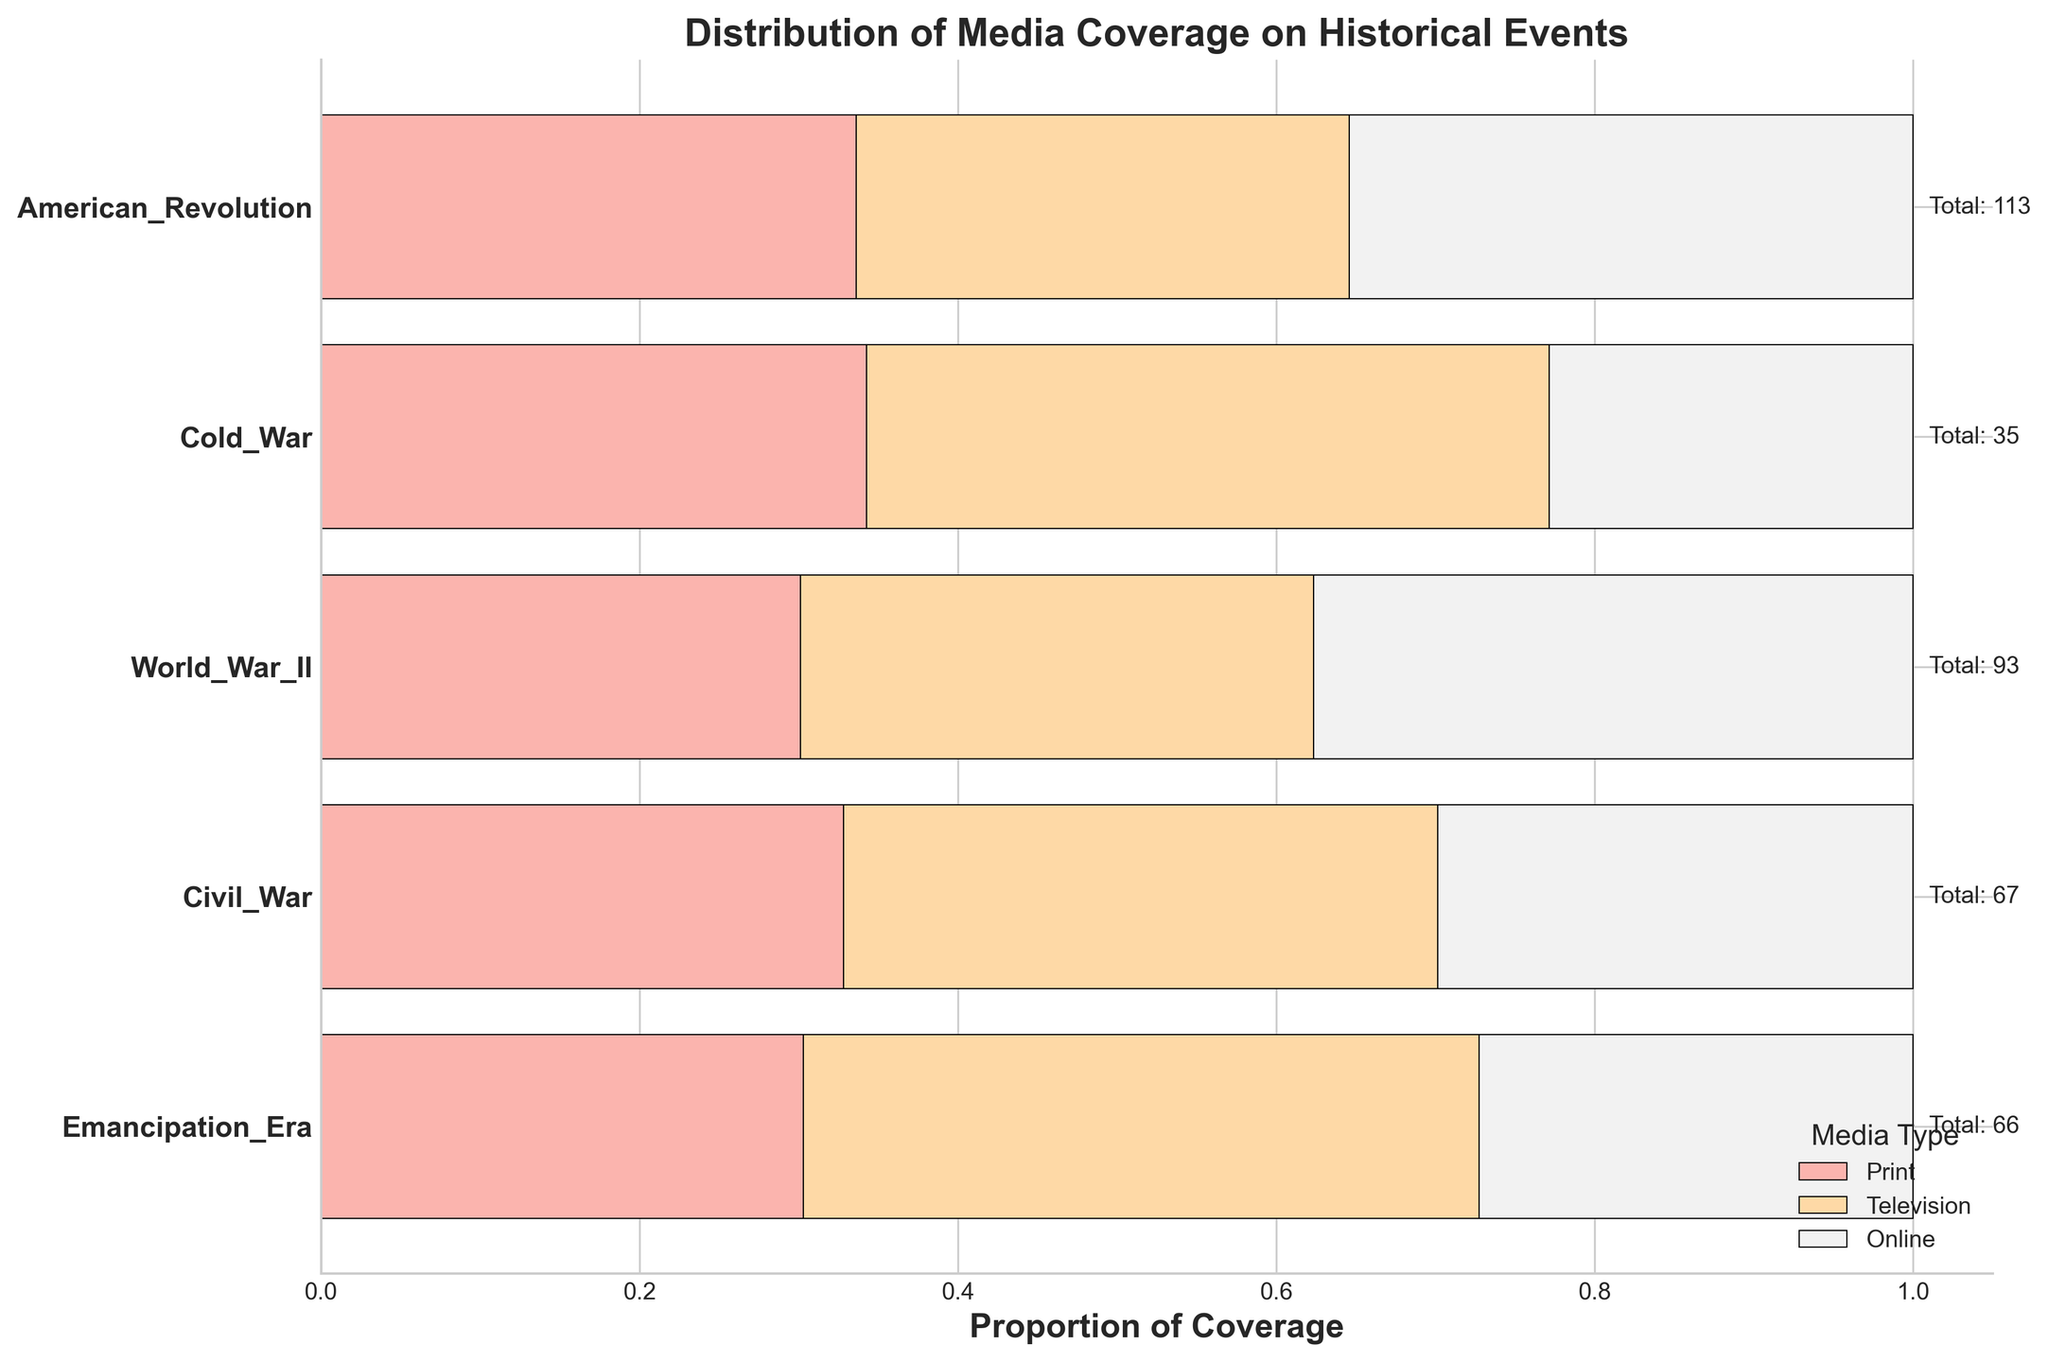What is the title of the plot? The title can be found at the top of the plot, usually in larger and bold text.
Answer: Distribution of Media Coverage on Historical Events Which historical period has the highest total media coverage? By looking at the "Total" values labeled at the end of each bar, the period with the highest number is identified.
Answer: World War II What proportion of media coverage for the Emancipation Era comes from online media? Locate the Emancipation Era bar, and observe the segment labeled for online media (typically a particular color). The width of this segment represents its proportion.
Answer: 12/35 Which media type has the highest coverage during the Cold War? In the Cold War bar, find the segment with the largest width; the legend provides the corresponding media type.
Answer: Television How does the television coverage of the Emancipation Era compare to that of the Civil War? Look at the television segment for both periods and compare their widths; the Civil War will have a wider segment than the Emancipation Era.
Answer: Lower What is the total coverage amount for the American Revolution? Look at the "Total" value labeled at the end of the bar for the American Revolution.
Answer: 66 Which historical period has the smallest proportion of print media coverage? Compare the widths of the print media segments across all periods; the Emancipation Era will have the smallest proportion of print coverage.
Answer: Emancipation Era Among the historical periods, which one has the least amount of online media coverage? Observe the size of online media segments across all periods; the Emancipation Era will have the smallest online media coverage.
Answer: Emancipation Era What percentage of the total media coverage does the Cold War period contribute? Sum up the total coverage across all periods and then calculate the percentage contribution from the Cold War period using its total.
Answer: (30 + 35 + 28)/(total coverage) 